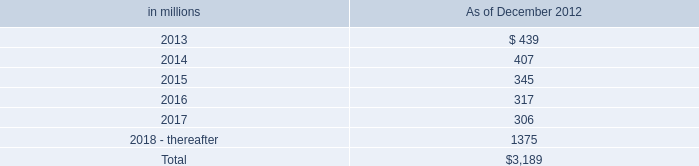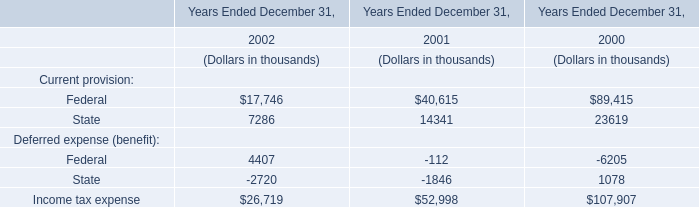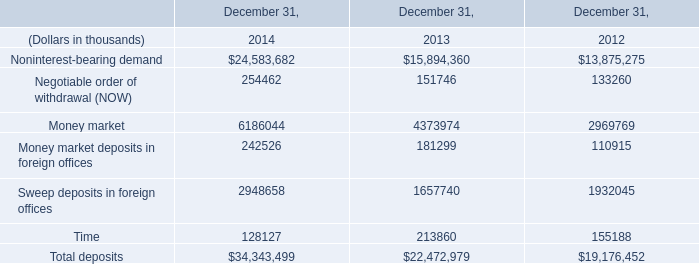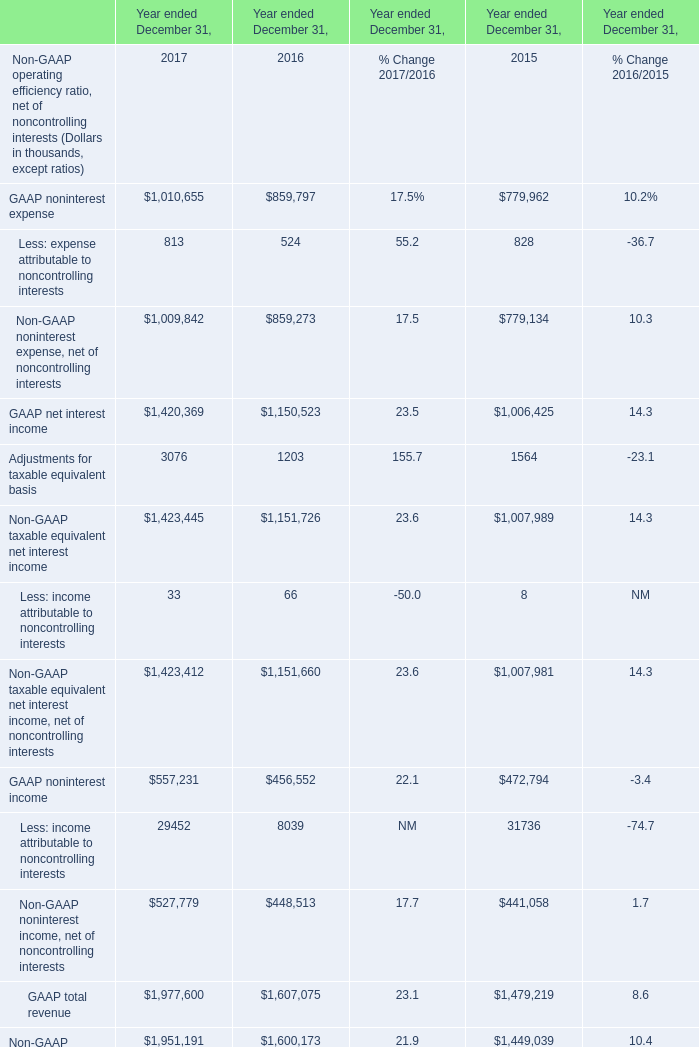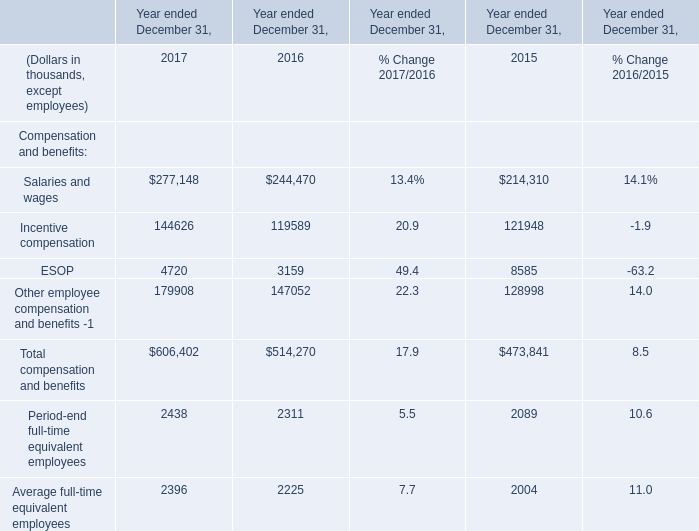What is the growing rate of GAAP noninterest income in the year with the most Non-GAAP taxable equivalent net interest income? (in %) 
Computations: ((557231 - 456552) / 557231)
Answer: 0.18068. 